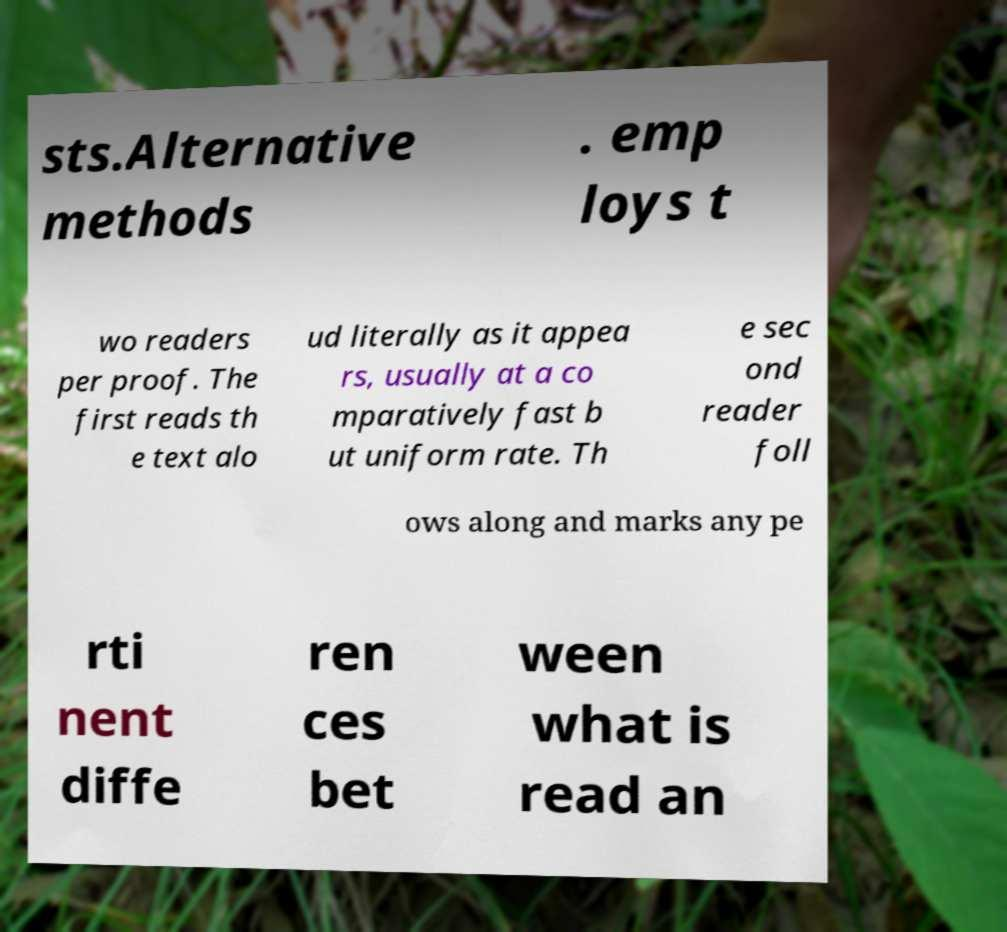Can you accurately transcribe the text from the provided image for me? sts.Alternative methods . emp loys t wo readers per proof. The first reads th e text alo ud literally as it appea rs, usually at a co mparatively fast b ut uniform rate. Th e sec ond reader foll ows along and marks any pe rti nent diffe ren ces bet ween what is read an 